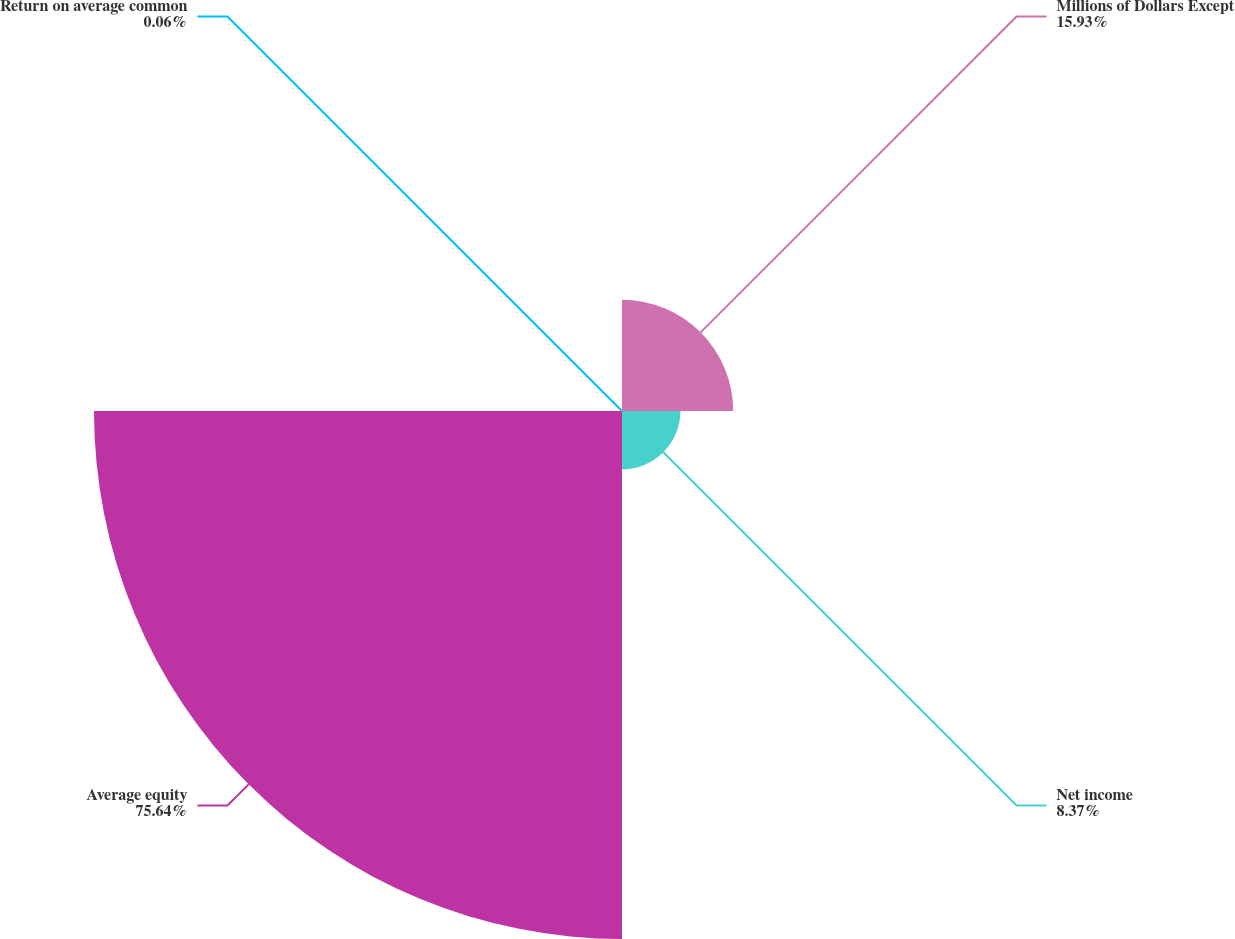<chart> <loc_0><loc_0><loc_500><loc_500><pie_chart><fcel>Millions of Dollars Except<fcel>Net income<fcel>Average equity<fcel>Return on average common<nl><fcel>15.93%<fcel>8.37%<fcel>75.64%<fcel>0.06%<nl></chart> 